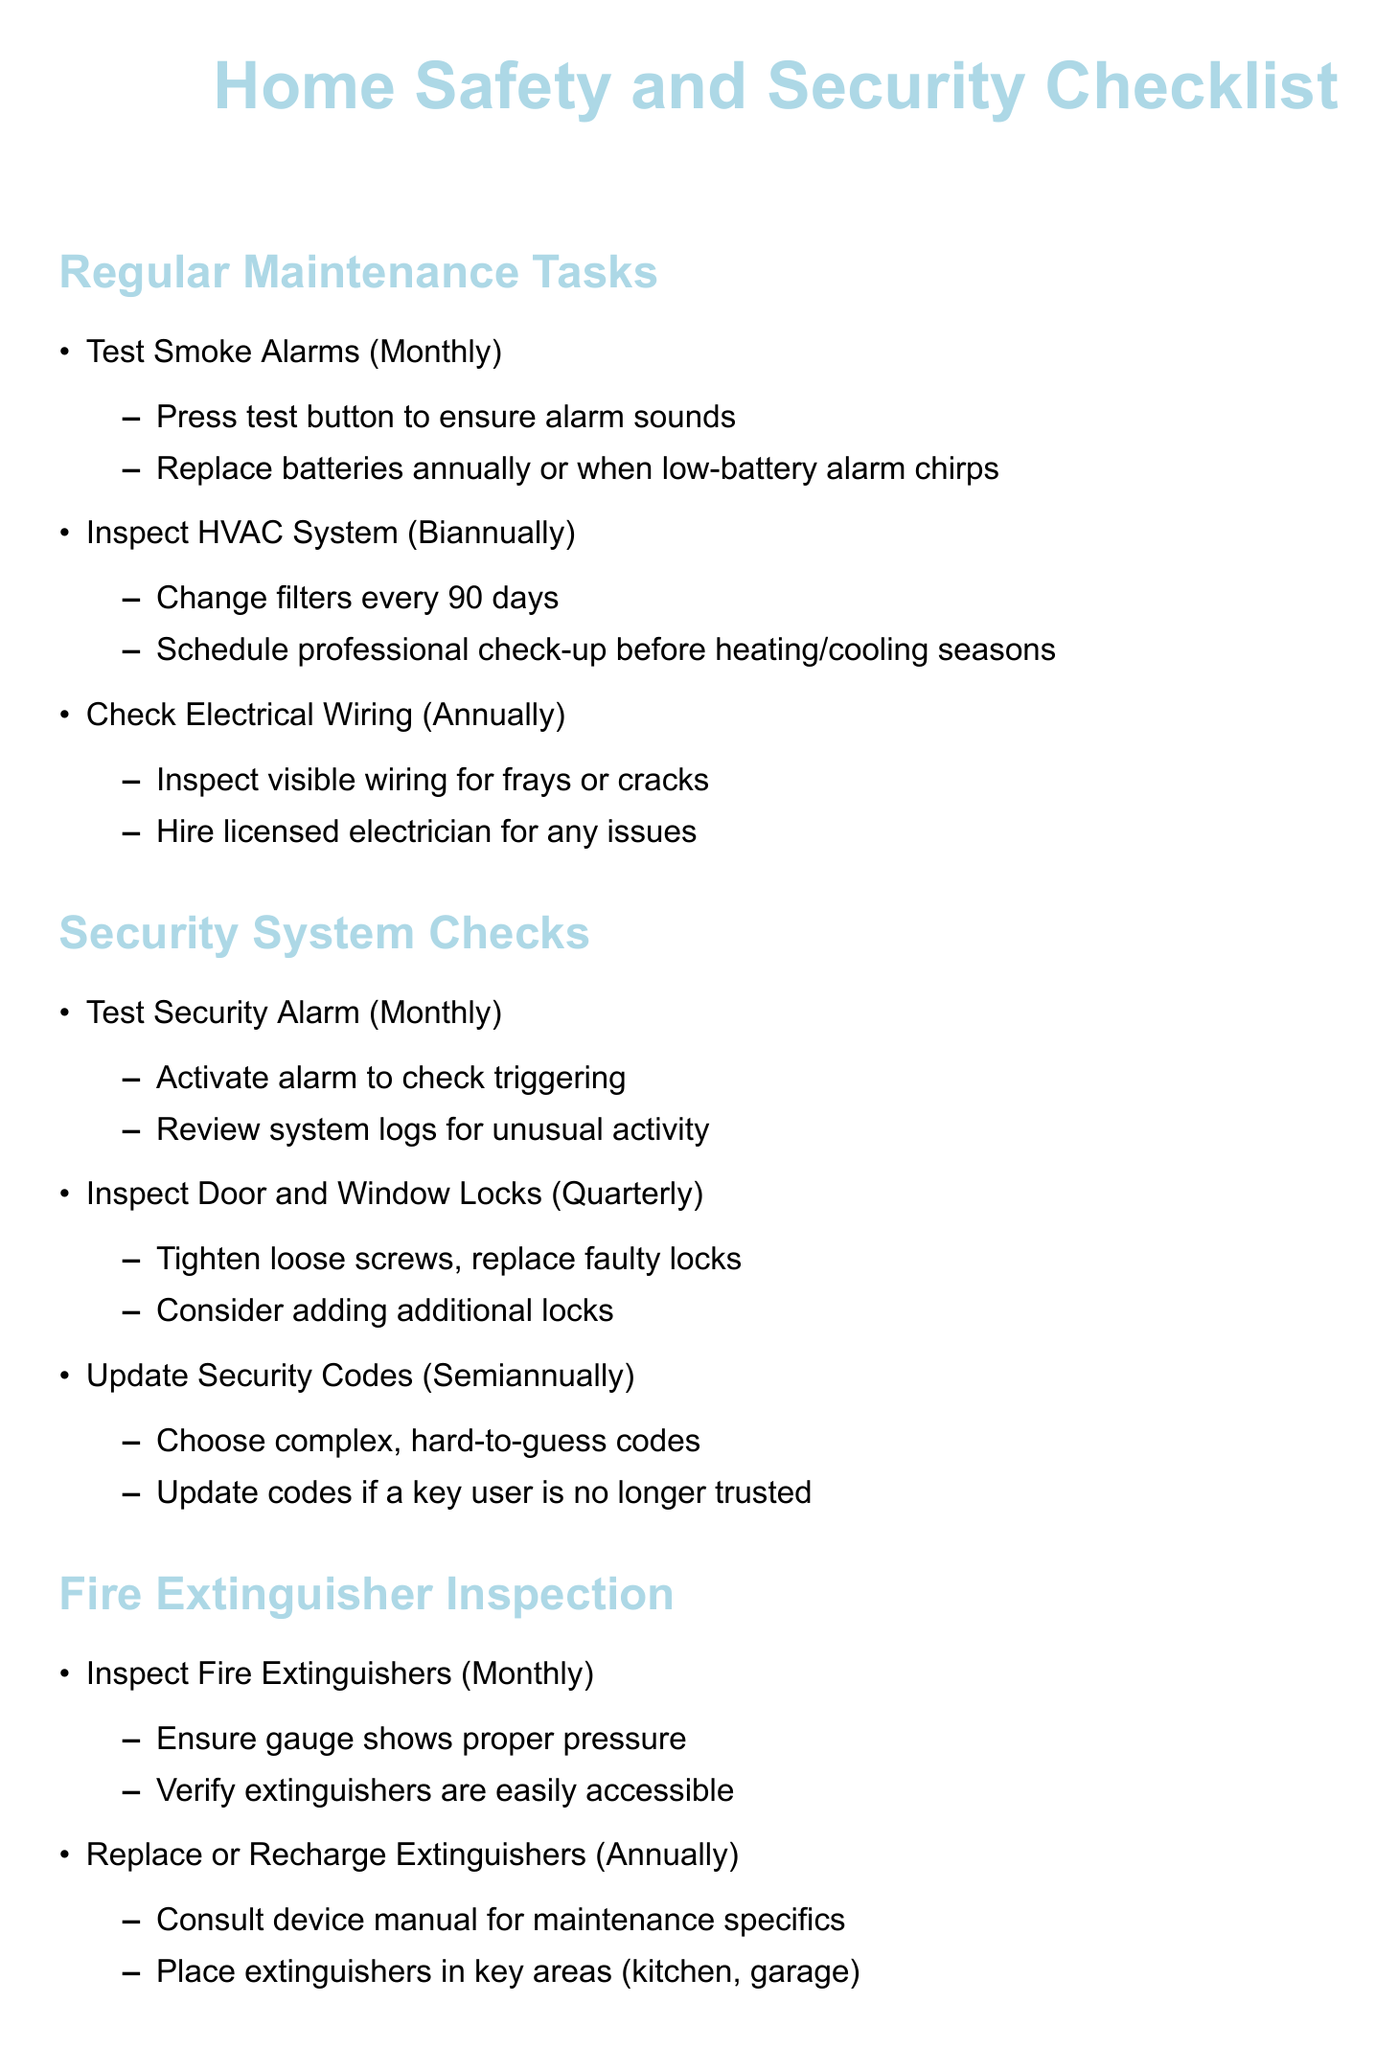What is the frequency for testing smoke alarms? The document states that smoke alarms should be tested monthly.
Answer: Monthly How often should the HVAC system be inspected? The HVAC system should be inspected biannually according to the document.
Answer: Biannually What should you do if you identify frayed wiring? The document advises hiring a licensed electrician for any wiring issues.
Answer: Hire licensed electrician How frequently should fire extinguishers be inspected? Fire extinguishers should be inspected monthly as stated in the checklist.
Answer: Monthly What is a recommended location for placing fire extinguishers? The document suggests placing extinguishers in key areas such as the kitchen and garage.
Answer: Kitchen, garage How often should security codes be updated? According to the document, security codes should be updated semiannually.
Answer: Semiannually What is the recommended safe storage for chemicals? The document recommends storing chemicals in locked cabinet away from children and pets.
Answer: Locked cabinet How often should expired materials be disposed of? The document indicates that expired materials should be disposed of annually.
Answer: Annually What should you do if a gas leak is detected? The document advises calling a professional immediately if a gas leak is detected.
Answer: Call professional immediately 